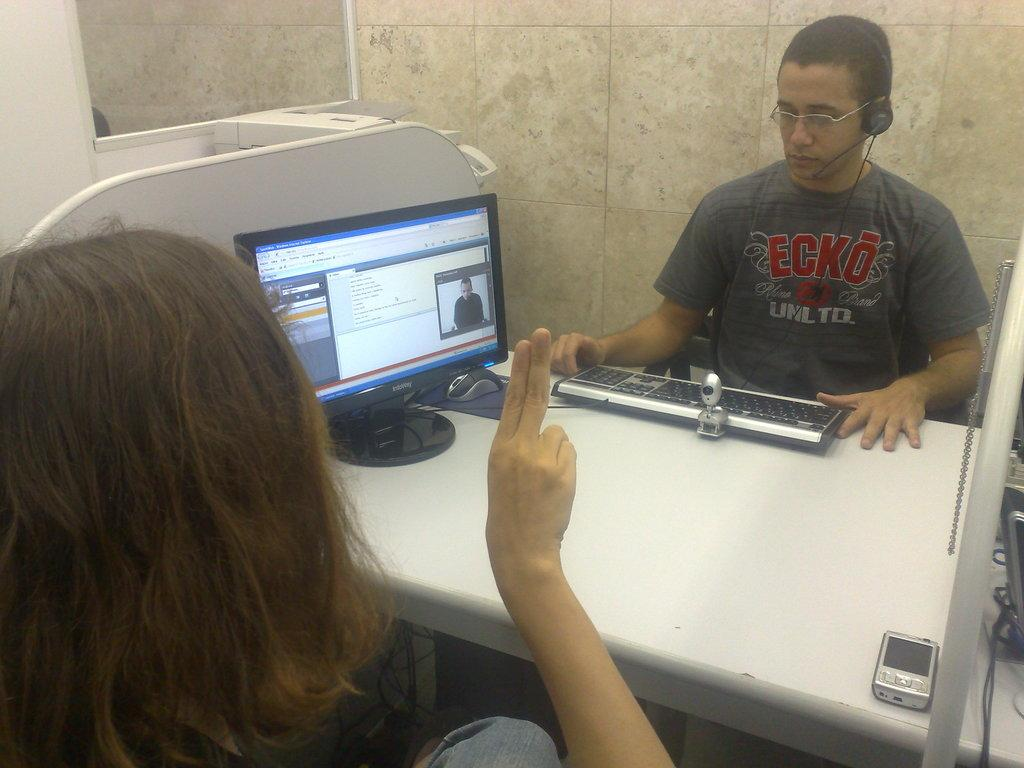<image>
Provide a brief description of the given image. A man wearing a shirt that has the letters ECKO on it. 